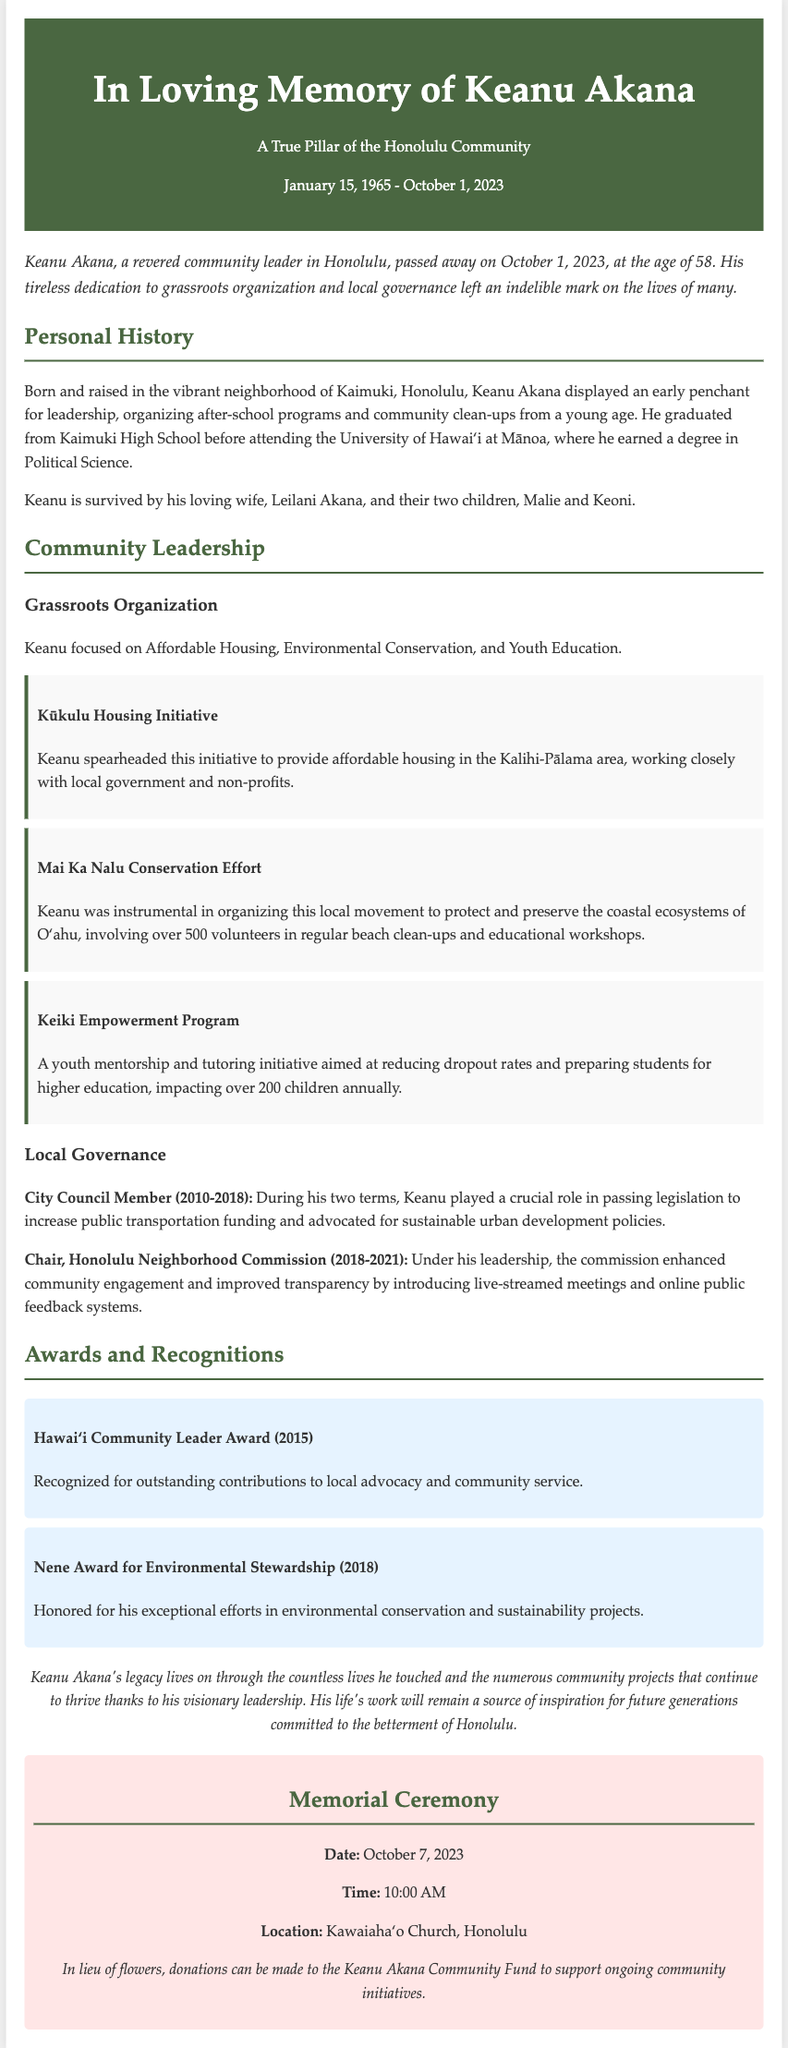What is the full name of the individual remembered in the obituary? The full name of the individual remembered is stated in the title of the document.
Answer: Keanu Akana What was Keanu Akana's age at the time of his passing? The document clearly mentions his age at the time of passing.
Answer: 58 What initiative did Keanu Akana spearhead for affordable housing? The document provides a specific title for the initiative related to housing.
Answer: Kūkulu Housing Initiative How many volunteers were involved in the Mai Ka Nalu Conservation Effort? The document quantifies the number of volunteers who participated in this conservation project.
Answer: 500 What city council position did Keanu Akana hold from 2010 to 2018? The document specifies the title of the position he held during this time.
Answer: City Council Member Which award did he receive in 2018 for environmental stewardship? The document lists the specific name of the award he received that year.
Answer: Nene Award for Environmental Stewardship What is the date of the memorial ceremony? The document explicitly states the date of the memorial ceremony.
Answer: October 7, 2023 Who is Keanu Akana survived by? The document mentions his family members mentioned as survivors.
Answer: Leilani Akana, Malie, and Keoni What type of programs did Keanu Akana help organize from a young age? The document provides a general description of activities he was involved in during his youth.
Answer: After-school programs and community clean-ups 